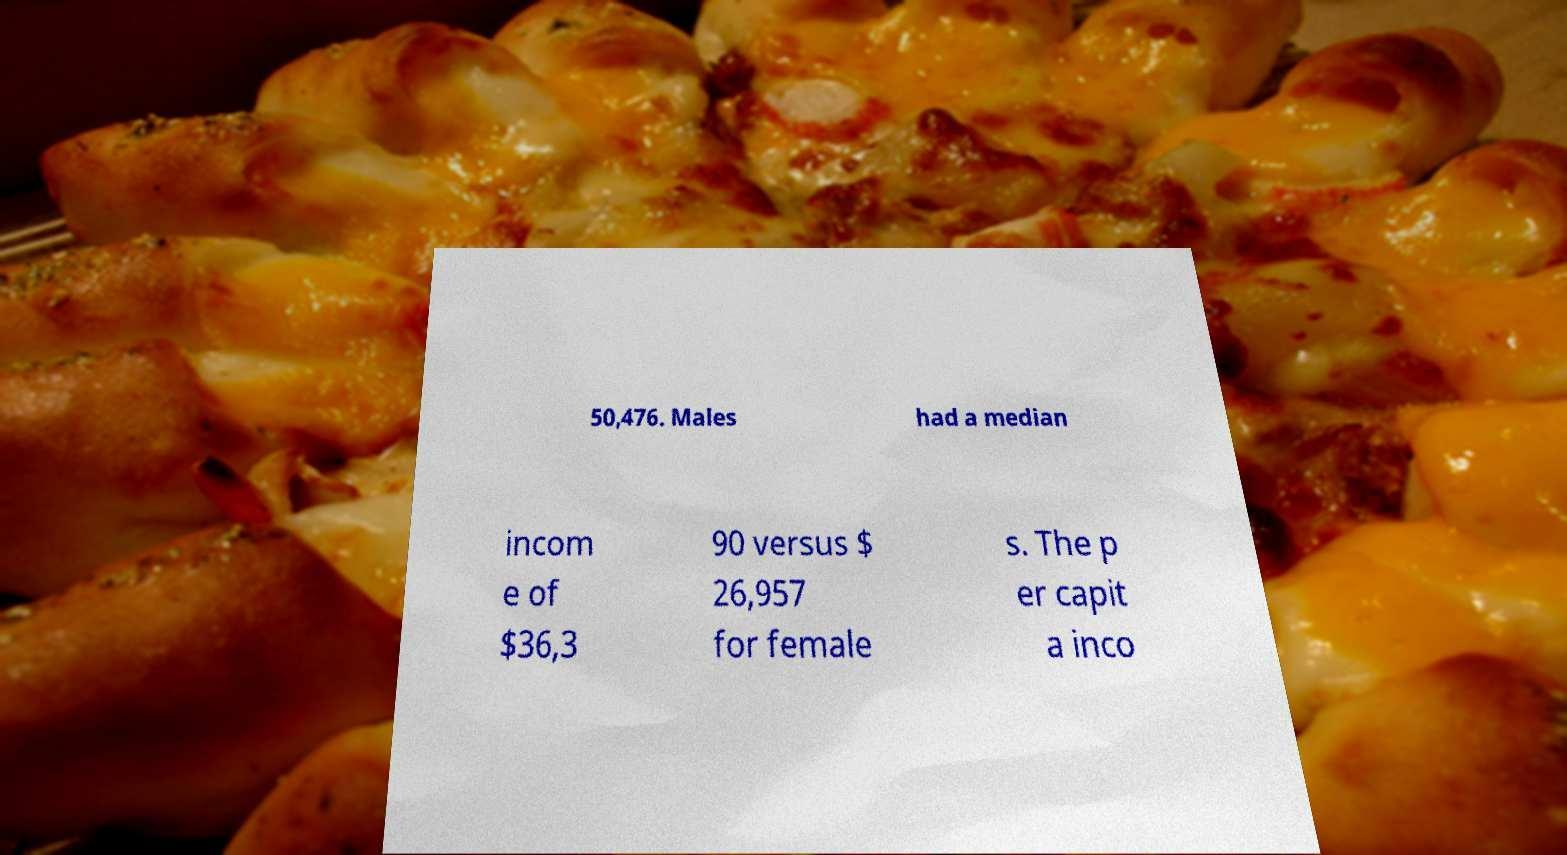Please read and relay the text visible in this image. What does it say? 50,476. Males had a median incom e of $36,3 90 versus $ 26,957 for female s. The p er capit a inco 